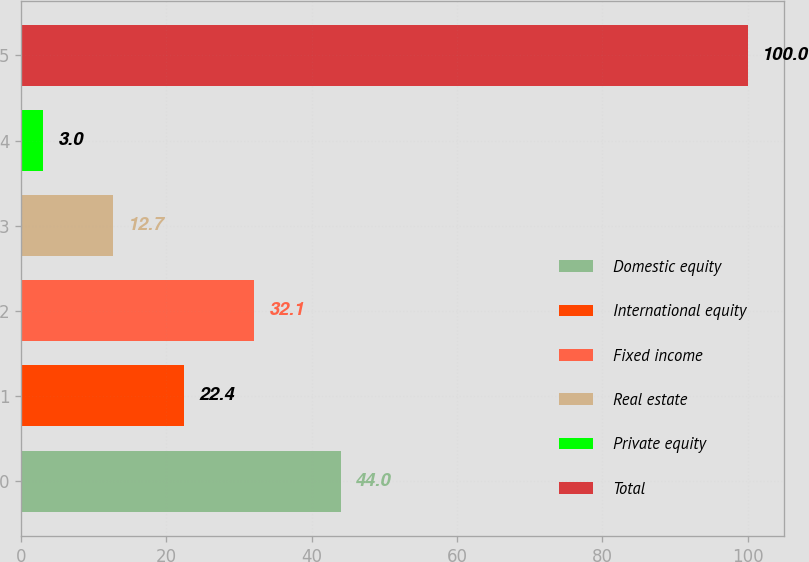Convert chart. <chart><loc_0><loc_0><loc_500><loc_500><bar_chart><fcel>Domestic equity<fcel>International equity<fcel>Fixed income<fcel>Real estate<fcel>Private equity<fcel>Total<nl><fcel>44<fcel>22.4<fcel>32.1<fcel>12.7<fcel>3<fcel>100<nl></chart> 